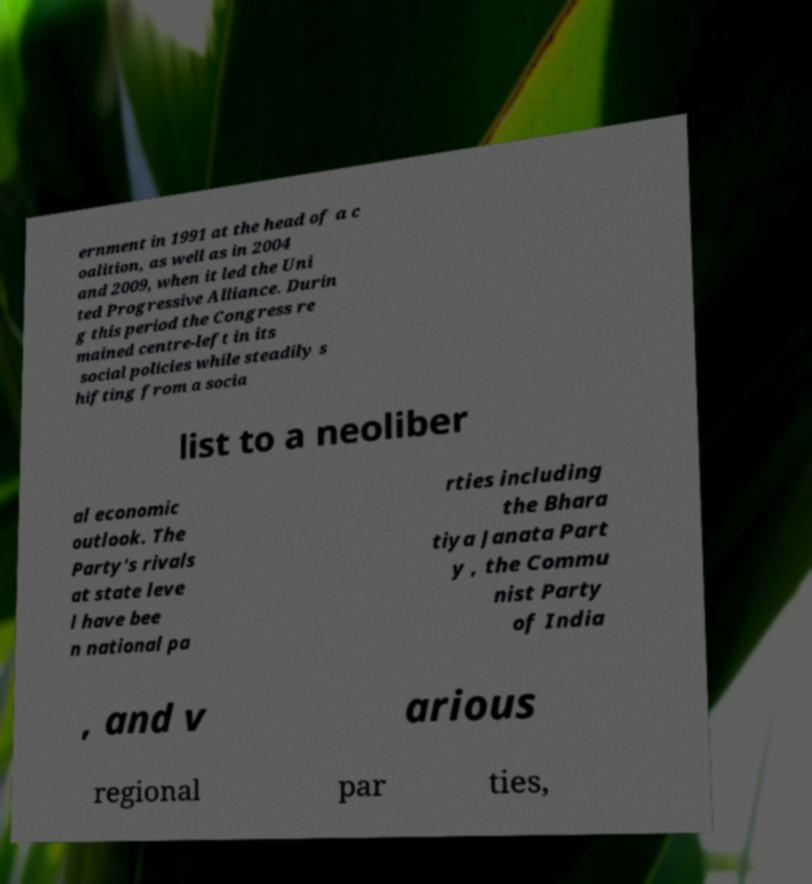Can you accurately transcribe the text from the provided image for me? ernment in 1991 at the head of a c oalition, as well as in 2004 and 2009, when it led the Uni ted Progressive Alliance. Durin g this period the Congress re mained centre-left in its social policies while steadily s hifting from a socia list to a neoliber al economic outlook. The Party's rivals at state leve l have bee n national pa rties including the Bhara tiya Janata Part y , the Commu nist Party of India , and v arious regional par ties, 